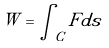Convert formula to latex. <formula><loc_0><loc_0><loc_500><loc_500>W = \int _ { C } F d s</formula> 